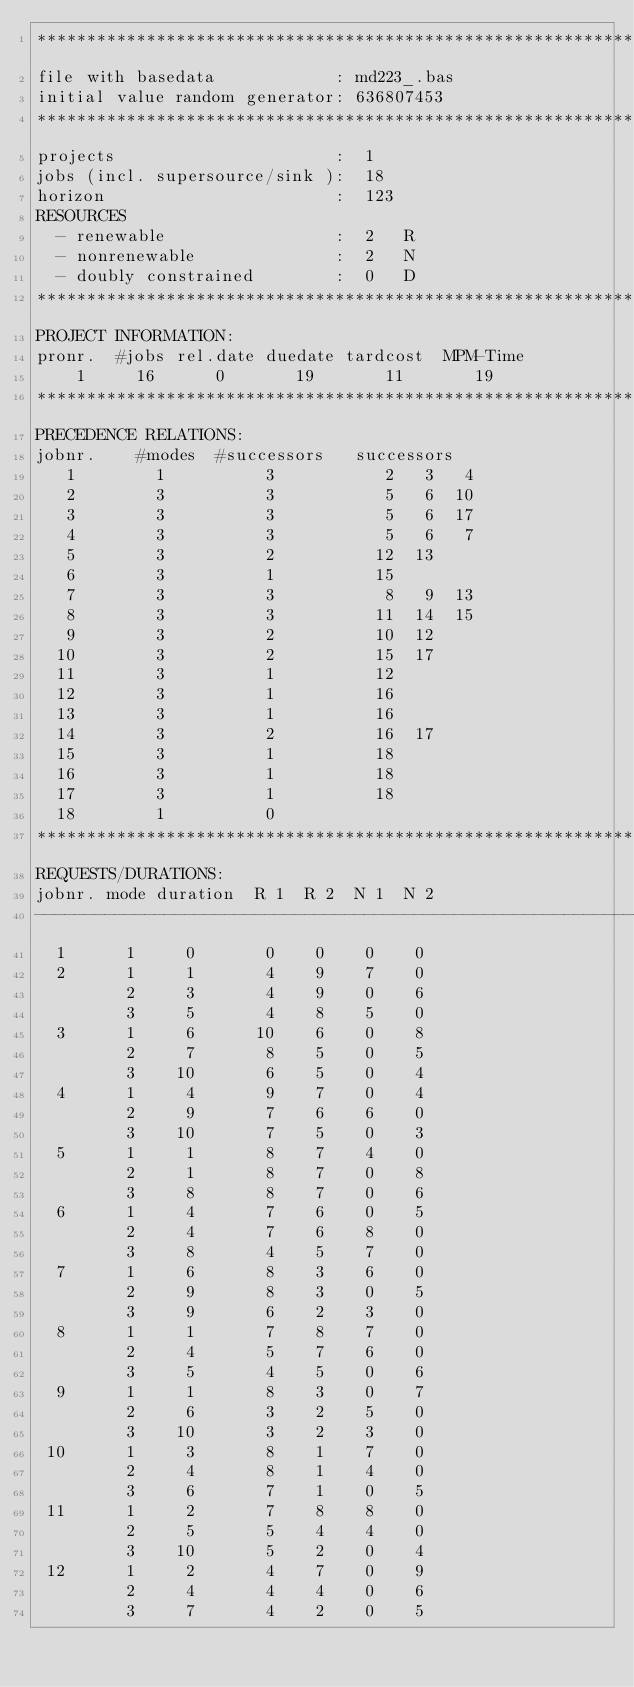<code> <loc_0><loc_0><loc_500><loc_500><_ObjectiveC_>************************************************************************
file with basedata            : md223_.bas
initial value random generator: 636807453
************************************************************************
projects                      :  1
jobs (incl. supersource/sink ):  18
horizon                       :  123
RESOURCES
  - renewable                 :  2   R
  - nonrenewable              :  2   N
  - doubly constrained        :  0   D
************************************************************************
PROJECT INFORMATION:
pronr.  #jobs rel.date duedate tardcost  MPM-Time
    1     16      0       19       11       19
************************************************************************
PRECEDENCE RELATIONS:
jobnr.    #modes  #successors   successors
   1        1          3           2   3   4
   2        3          3           5   6  10
   3        3          3           5   6  17
   4        3          3           5   6   7
   5        3          2          12  13
   6        3          1          15
   7        3          3           8   9  13
   8        3          3          11  14  15
   9        3          2          10  12
  10        3          2          15  17
  11        3          1          12
  12        3          1          16
  13        3          1          16
  14        3          2          16  17
  15        3          1          18
  16        3          1          18
  17        3          1          18
  18        1          0        
************************************************************************
REQUESTS/DURATIONS:
jobnr. mode duration  R 1  R 2  N 1  N 2
------------------------------------------------------------------------
  1      1     0       0    0    0    0
  2      1     1       4    9    7    0
         2     3       4    9    0    6
         3     5       4    8    5    0
  3      1     6      10    6    0    8
         2     7       8    5    0    5
         3    10       6    5    0    4
  4      1     4       9    7    0    4
         2     9       7    6    6    0
         3    10       7    5    0    3
  5      1     1       8    7    4    0
         2     1       8    7    0    8
         3     8       8    7    0    6
  6      1     4       7    6    0    5
         2     4       7    6    8    0
         3     8       4    5    7    0
  7      1     6       8    3    6    0
         2     9       8    3    0    5
         3     9       6    2    3    0
  8      1     1       7    8    7    0
         2     4       5    7    6    0
         3     5       4    5    0    6
  9      1     1       8    3    0    7
         2     6       3    2    5    0
         3    10       3    2    3    0
 10      1     3       8    1    7    0
         2     4       8    1    4    0
         3     6       7    1    0    5
 11      1     2       7    8    8    0
         2     5       5    4    4    0
         3    10       5    2    0    4
 12      1     2       4    7    0    9
         2     4       4    4    0    6
         3     7       4    2    0    5</code> 